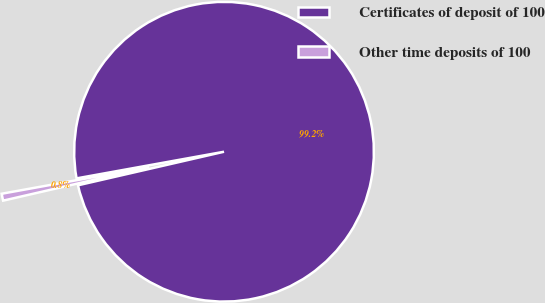<chart> <loc_0><loc_0><loc_500><loc_500><pie_chart><fcel>Certificates of deposit of 100<fcel>Other time deposits of 100<nl><fcel>99.25%<fcel>0.75%<nl></chart> 